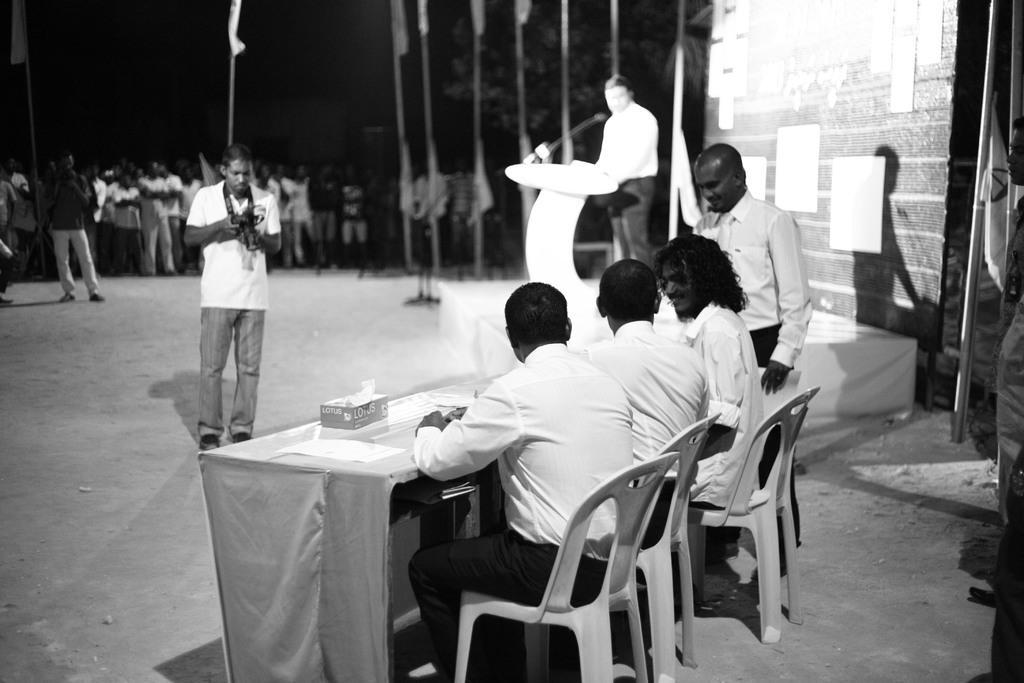Could you give a brief overview of what you see in this image? In this picture we can see three people sitting on chair, in the background we can see a group of people standing and looking at them, in the middle a man is standing and looking at digital camera, on the right side of the picture there is a man standing in front of a speech desk, we can see a microphone here, on the right side of the picture there is a wall. 